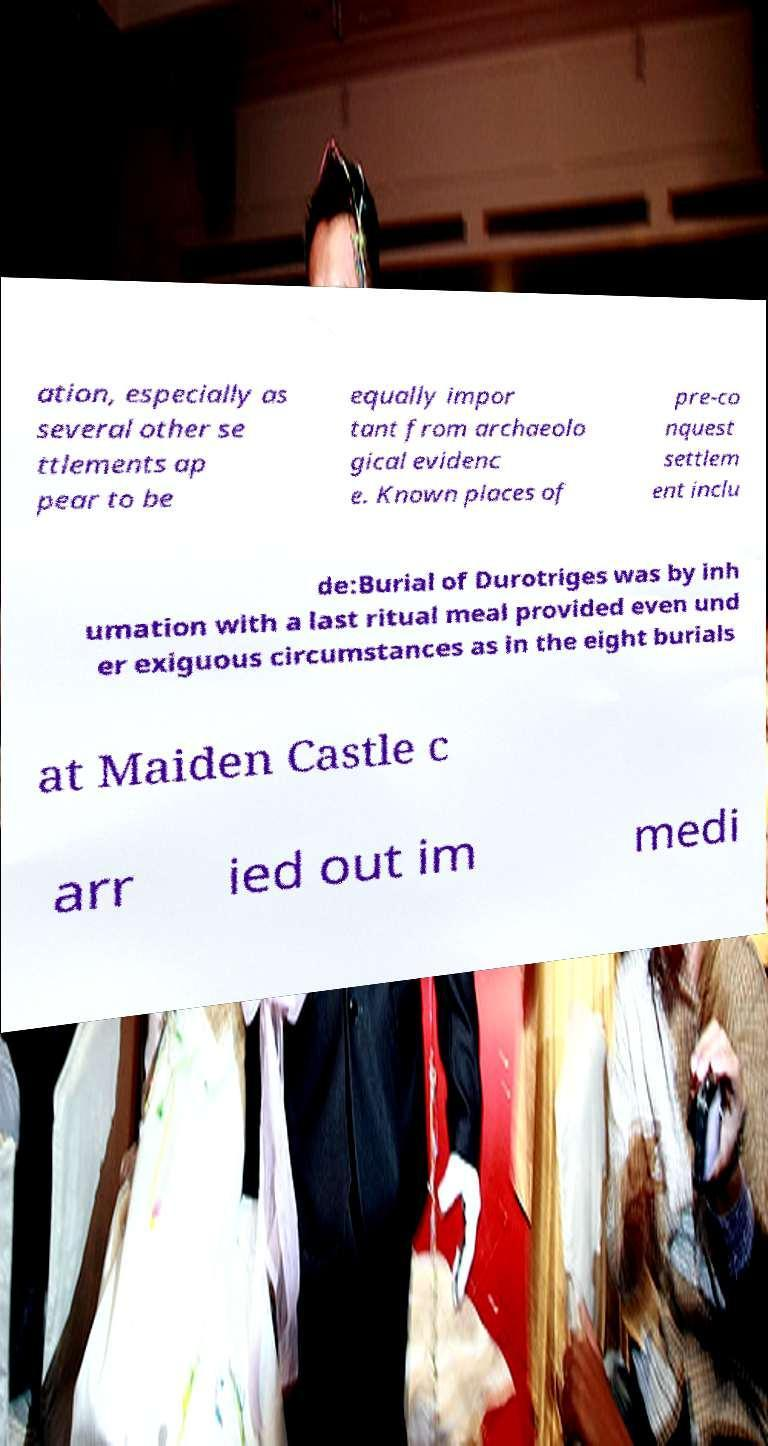Can you read and provide the text displayed in the image?This photo seems to have some interesting text. Can you extract and type it out for me? ation, especially as several other se ttlements ap pear to be equally impor tant from archaeolo gical evidenc e. Known places of pre-co nquest settlem ent inclu de:Burial of Durotriges was by inh umation with a last ritual meal provided even und er exiguous circumstances as in the eight burials at Maiden Castle c arr ied out im medi 